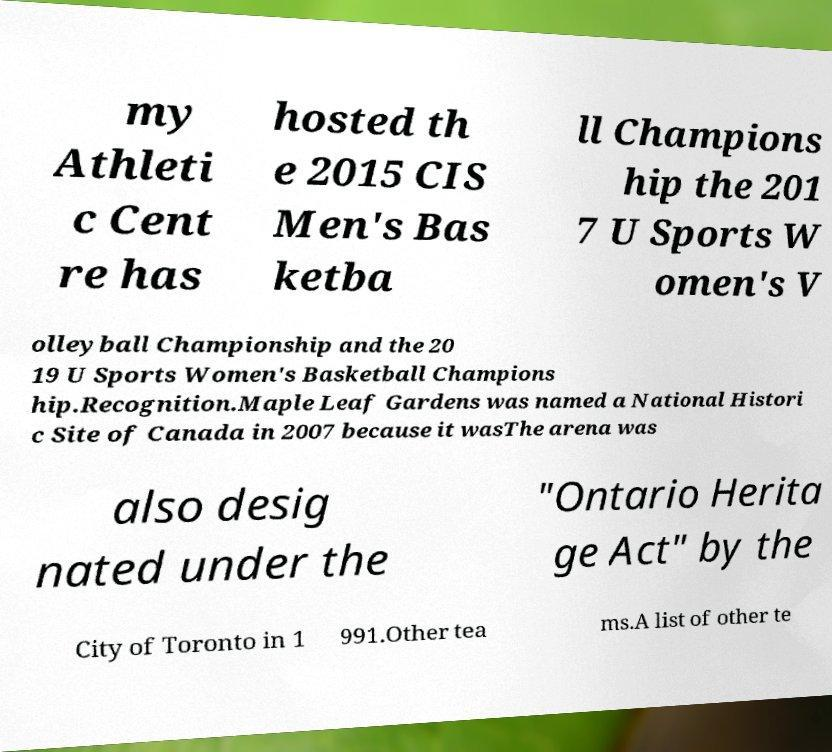I need the written content from this picture converted into text. Can you do that? my Athleti c Cent re has hosted th e 2015 CIS Men's Bas ketba ll Champions hip the 201 7 U Sports W omen's V olleyball Championship and the 20 19 U Sports Women's Basketball Champions hip.Recognition.Maple Leaf Gardens was named a National Histori c Site of Canada in 2007 because it wasThe arena was also desig nated under the "Ontario Herita ge Act" by the City of Toronto in 1 991.Other tea ms.A list of other te 